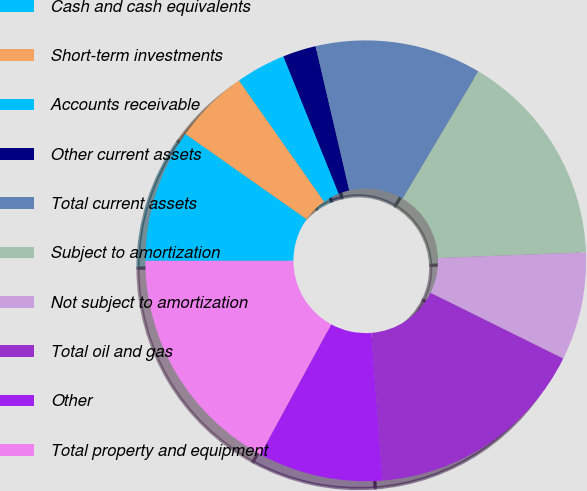Convert chart. <chart><loc_0><loc_0><loc_500><loc_500><pie_chart><fcel>Cash and cash equivalents<fcel>Short-term investments<fcel>Accounts receivable<fcel>Other current assets<fcel>Total current assets<fcel>Subject to amortization<fcel>Not subject to amortization<fcel>Total oil and gas<fcel>Other<fcel>Total property and equipment<nl><fcel>9.76%<fcel>5.49%<fcel>3.66%<fcel>2.44%<fcel>12.19%<fcel>15.85%<fcel>7.93%<fcel>16.46%<fcel>9.15%<fcel>17.07%<nl></chart> 